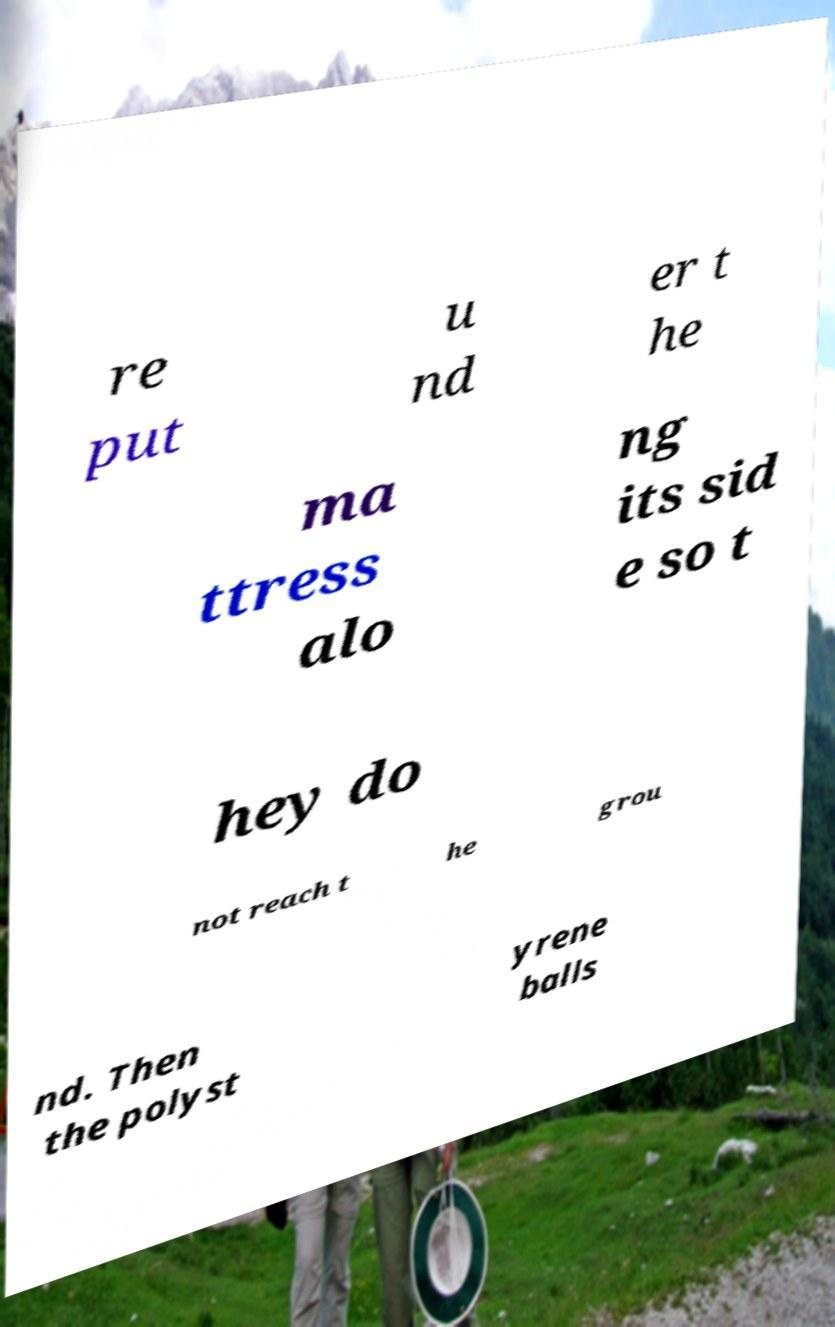Could you assist in decoding the text presented in this image and type it out clearly? re put u nd er t he ma ttress alo ng its sid e so t hey do not reach t he grou nd. Then the polyst yrene balls 